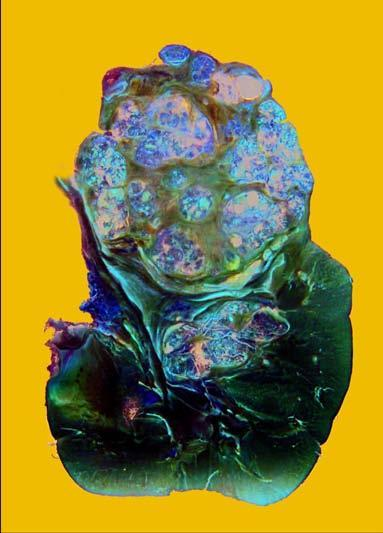does inbox in the right photomicrograph show irregular, circumscribed, yellowish mass with areas of haemorrhages and necrosis?
Answer the question using a single word or phrase. No 